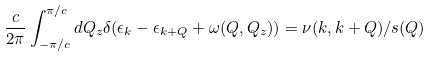Convert formula to latex. <formula><loc_0><loc_0><loc_500><loc_500>\frac { c } { 2 \pi } \int _ { - \pi / c } ^ { \pi / c } d Q _ { z } \delta ( \epsilon _ { k } - \epsilon _ { k + Q } + \omega ( Q , Q _ { z } ) ) = \nu ( k , k + Q ) / s ( Q )</formula> 